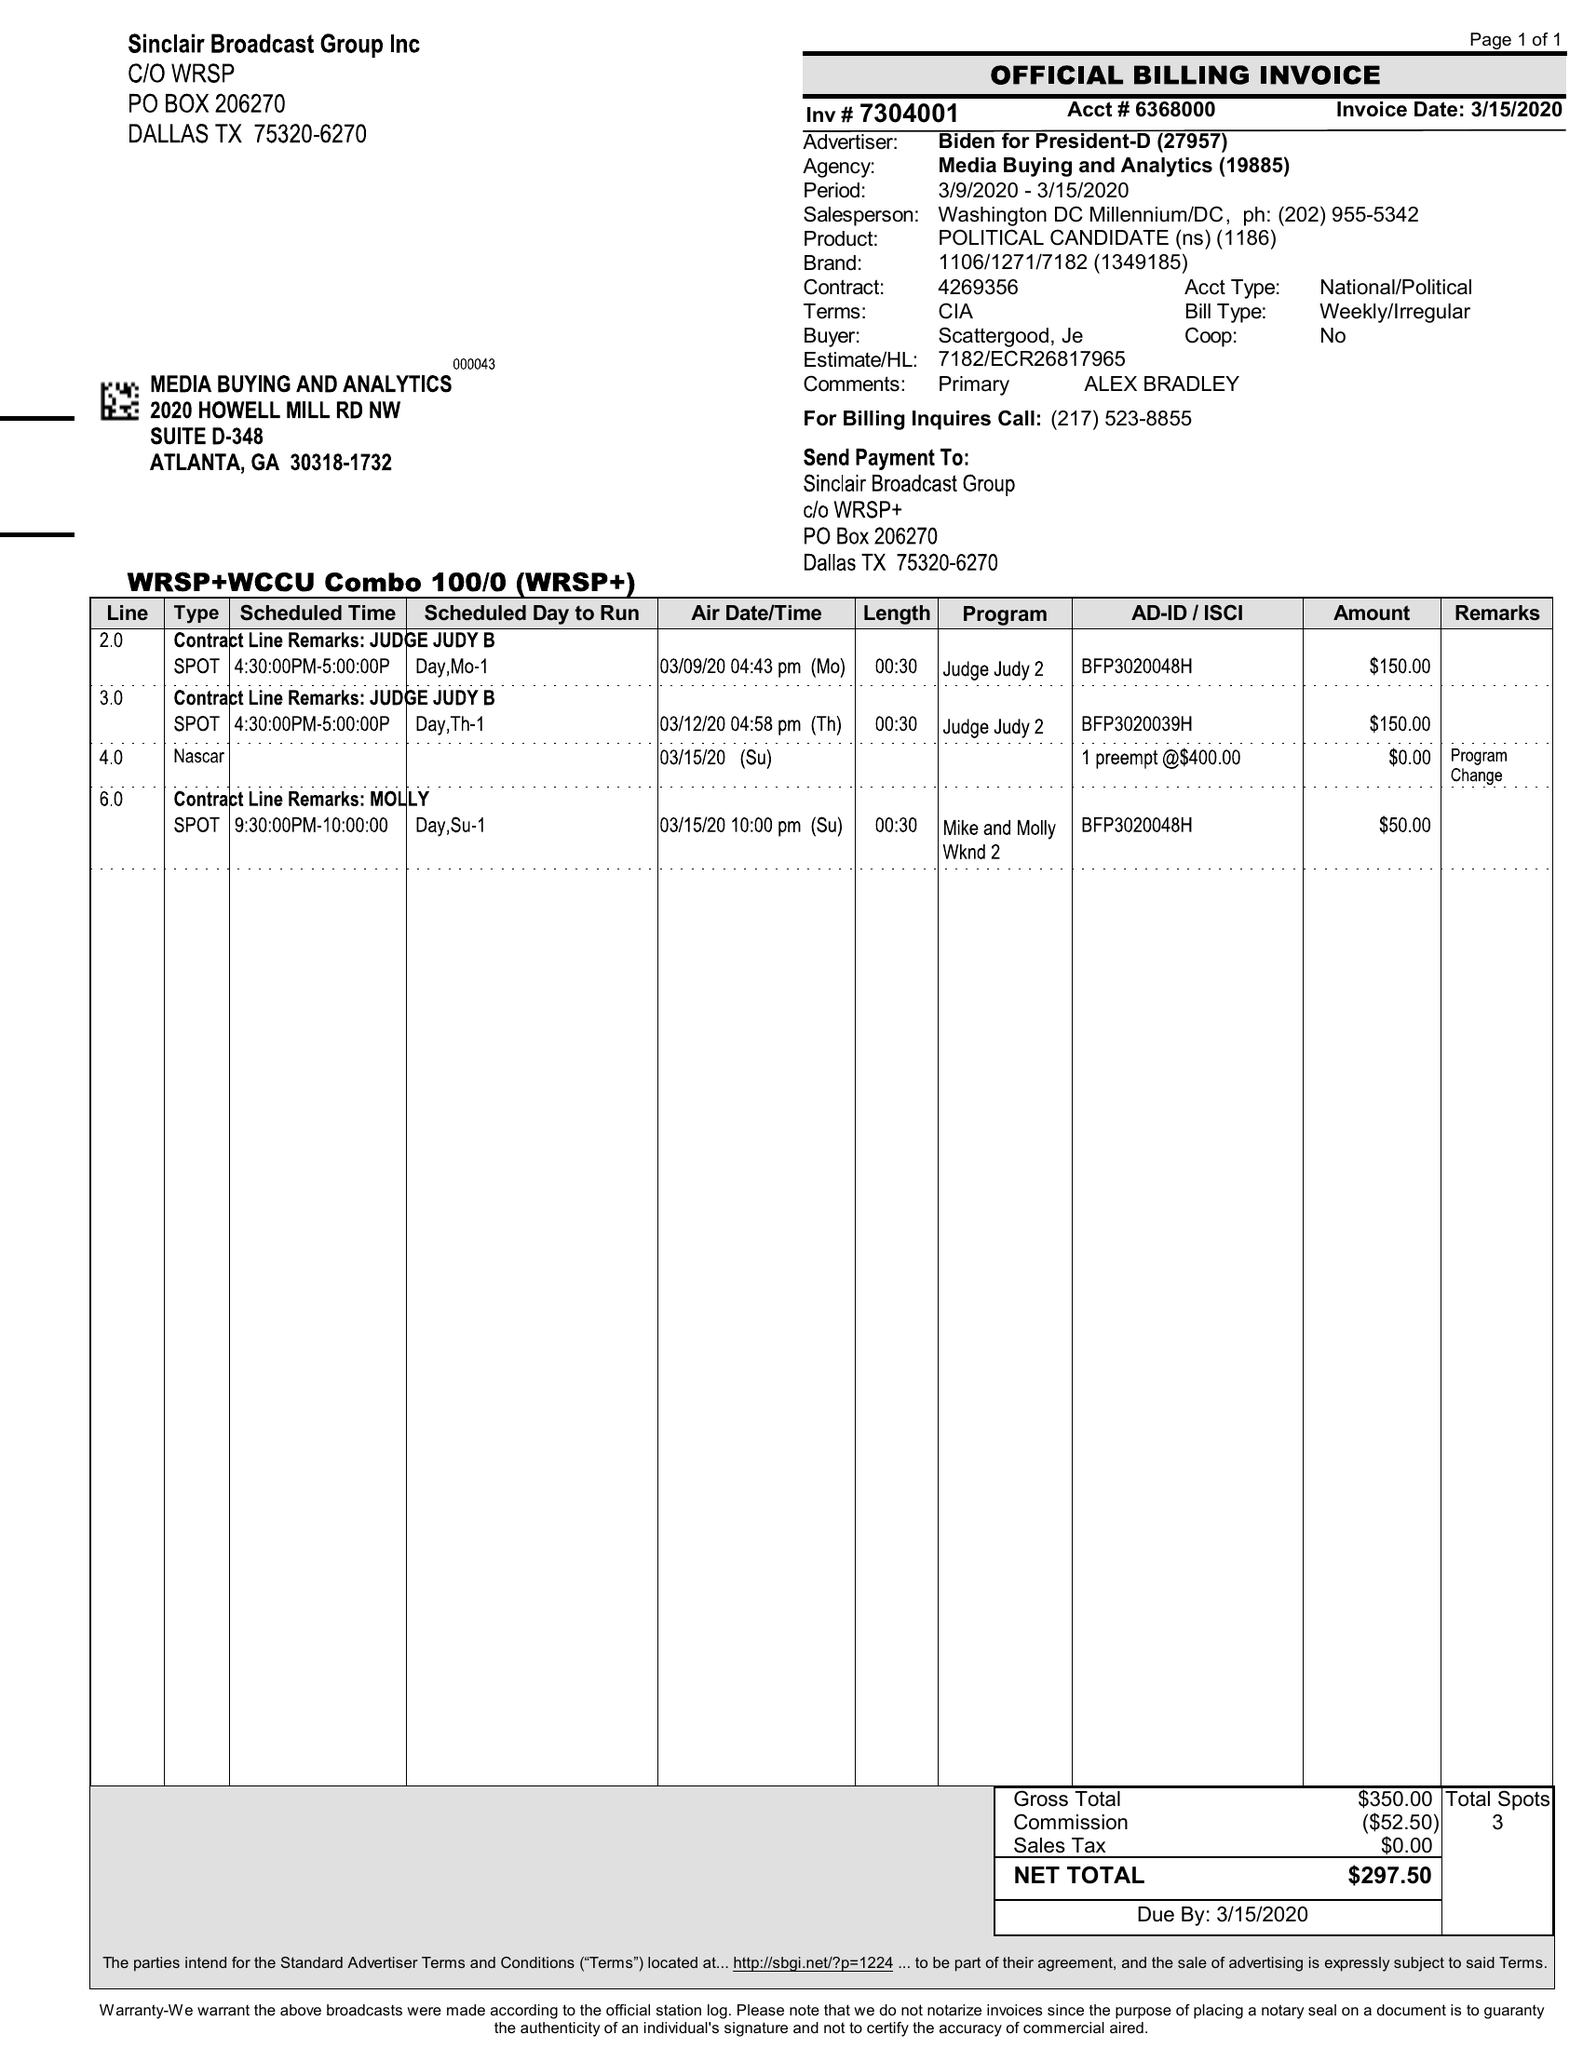What is the value for the contract_num?
Answer the question using a single word or phrase. 7304001 